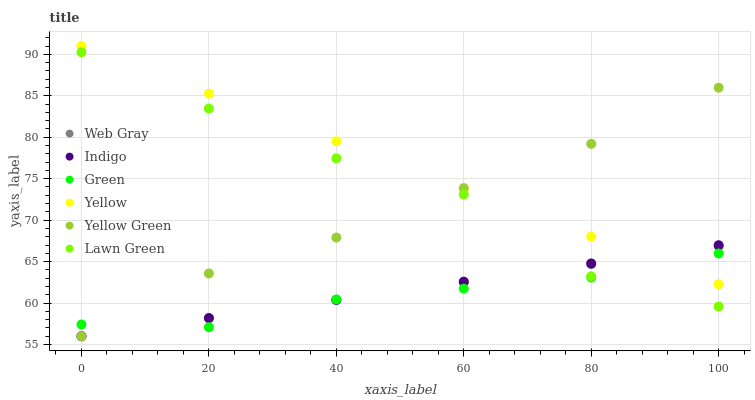Does Green have the minimum area under the curve?
Answer yes or no. Yes. Does Yellow have the maximum area under the curve?
Answer yes or no. Yes. Does Web Gray have the minimum area under the curve?
Answer yes or no. No. Does Web Gray have the maximum area under the curve?
Answer yes or no. No. Is Web Gray the smoothest?
Answer yes or no. Yes. Is Lawn Green the roughest?
Answer yes or no. Yes. Is Indigo the smoothest?
Answer yes or no. No. Is Indigo the roughest?
Answer yes or no. No. Does Web Gray have the lowest value?
Answer yes or no. Yes. Does Yellow have the lowest value?
Answer yes or no. No. Does Yellow have the highest value?
Answer yes or no. Yes. Does Web Gray have the highest value?
Answer yes or no. No. Is Lawn Green less than Yellow?
Answer yes or no. Yes. Is Yellow greater than Lawn Green?
Answer yes or no. Yes. Does Green intersect Web Gray?
Answer yes or no. Yes. Is Green less than Web Gray?
Answer yes or no. No. Is Green greater than Web Gray?
Answer yes or no. No. Does Lawn Green intersect Yellow?
Answer yes or no. No. 